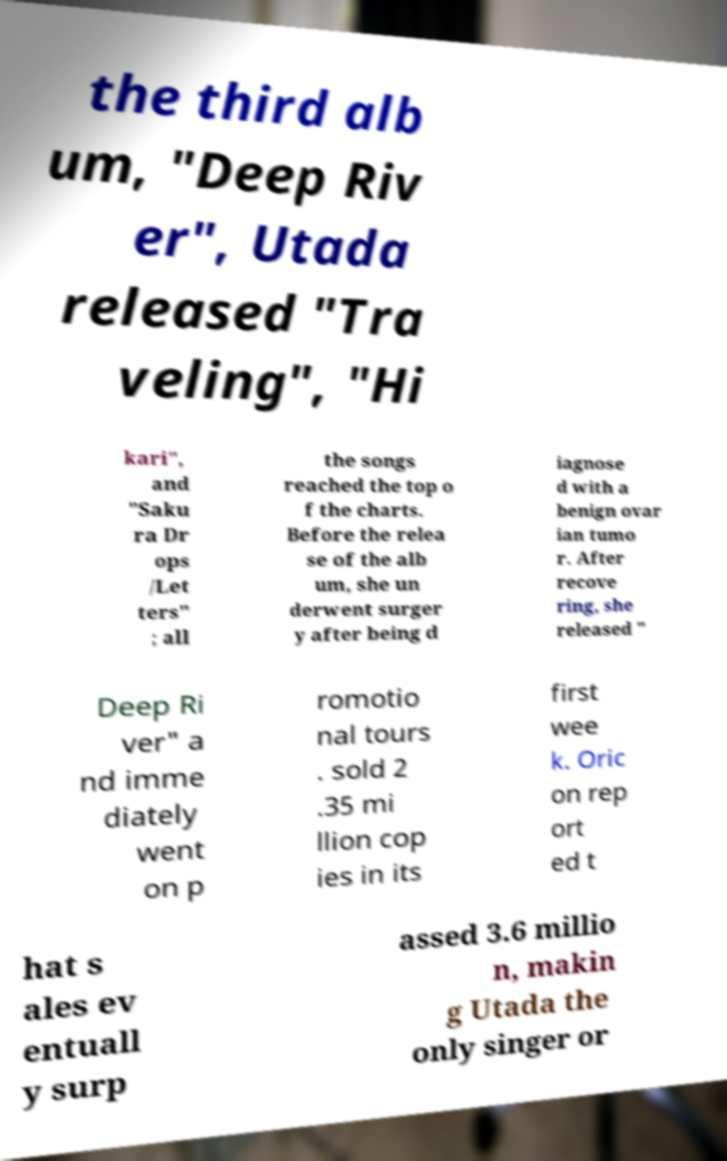There's text embedded in this image that I need extracted. Can you transcribe it verbatim? the third alb um, "Deep Riv er", Utada released "Tra veling", "Hi kari", and "Saku ra Dr ops /Let ters" ; all the songs reached the top o f the charts. Before the relea se of the alb um, she un derwent surger y after being d iagnose d with a benign ovar ian tumo r. After recove ring, she released " Deep Ri ver" a nd imme diately went on p romotio nal tours . sold 2 .35 mi llion cop ies in its first wee k. Oric on rep ort ed t hat s ales ev entuall y surp assed 3.6 millio n, makin g Utada the only singer or 